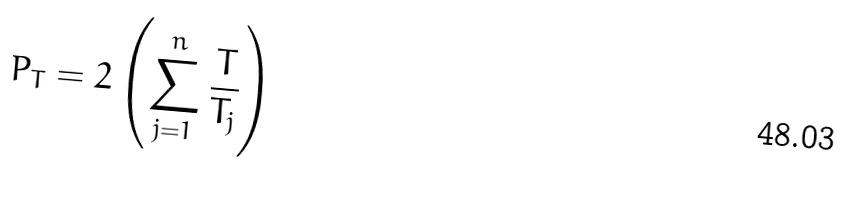Convert formula to latex. <formula><loc_0><loc_0><loc_500><loc_500>P _ { T } = 2 \left ( \sum _ { j = 1 } ^ { n } \frac { T } { T _ { j } } \right )</formula> 